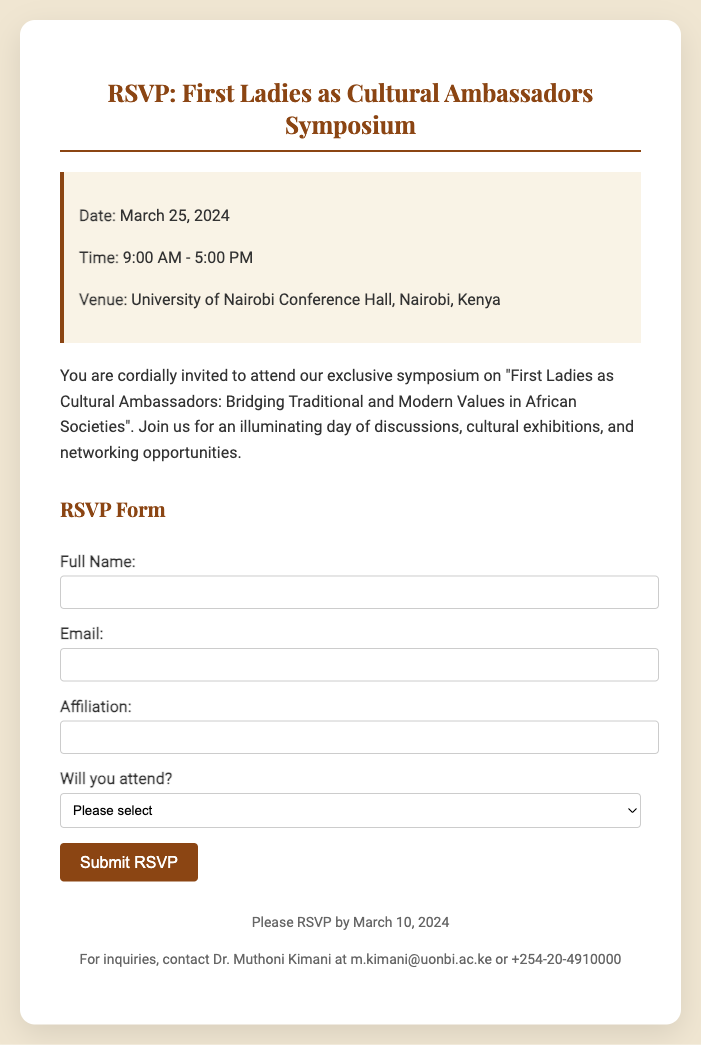what is the date of the symposium? The date of the symposium is clearly stated in the event details section of the document.
Answer: March 25, 2024 what is the venue for the event? The venue is mentioned in the event details, indicating where the symposium will take place.
Answer: University of Nairobi Conference Hall, Nairobi, Kenya what time does the symposium start? The starting time is provided in the event details, showing when participants can begin attending.
Answer: 9:00 AM who should be contacted for inquiries? The contact person for inquiries is specified at the bottom of the document, directing attendees for further questions.
Answer: Dr. Muthoni Kimani what is the RSVP deadline? The deadline for RSVPs is indicated in the footer of the document for planning purposes.
Answer: March 10, 2024 how long will the symposium last? The duration can be derived from the starting and ending times mentioned in the event details.
Answer: 8 hours what type of opportunities will be available at the symposium? The document mentions multiple activities, indicating what participants can expect during the event.
Answer: networking opportunities what is the theme of the symposium? The theme is presented in the introduction of the document, which reflects the focus of the discussions.
Answer: First Ladies as Cultural Ambassadors: Bridging Traditional and Modern Values in African Societies 